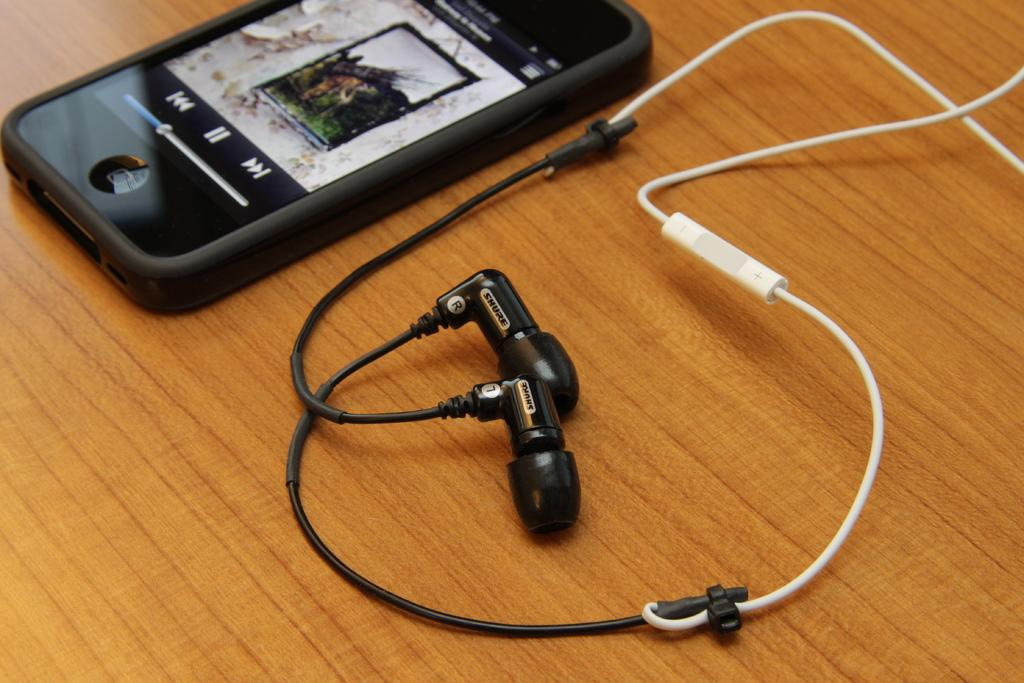What electronic device is visible in the picture? There is a mobile phone in the picture. What is being displayed on the mobile phone? Something is displayed on the mobile phone. What accessory is present in the picture? Earphones are present in the picture. On what surface are the earphones placed? The earphones are placed on a wooden surface. What type of quill is being used to write on the mobile phone? There is no quill present in the image, and the mobile phone is not being used for writing. 